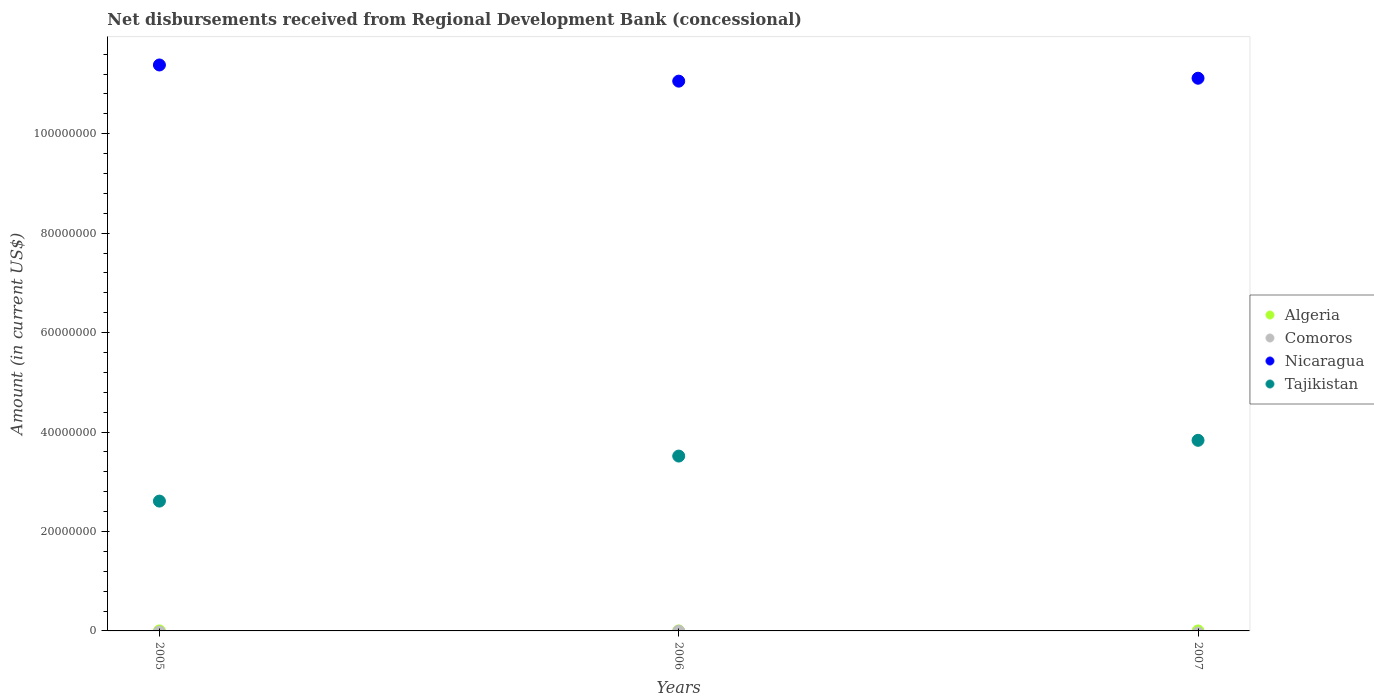How many different coloured dotlines are there?
Provide a short and direct response. 2. What is the amount of disbursements received from Regional Development Bank in Algeria in 2005?
Offer a very short reply. 0. Across all years, what is the maximum amount of disbursements received from Regional Development Bank in Nicaragua?
Your answer should be compact. 1.14e+08. Across all years, what is the minimum amount of disbursements received from Regional Development Bank in Tajikistan?
Provide a succinct answer. 2.61e+07. In which year was the amount of disbursements received from Regional Development Bank in Tajikistan maximum?
Provide a short and direct response. 2007. What is the difference between the amount of disbursements received from Regional Development Bank in Nicaragua in 2005 and that in 2007?
Give a very brief answer. 2.66e+06. What is the difference between the amount of disbursements received from Regional Development Bank in Tajikistan in 2006 and the amount of disbursements received from Regional Development Bank in Comoros in 2005?
Ensure brevity in your answer.  3.52e+07. What is the average amount of disbursements received from Regional Development Bank in Tajikistan per year?
Your answer should be compact. 3.32e+07. In the year 2006, what is the difference between the amount of disbursements received from Regional Development Bank in Tajikistan and amount of disbursements received from Regional Development Bank in Nicaragua?
Provide a succinct answer. -7.54e+07. In how many years, is the amount of disbursements received from Regional Development Bank in Nicaragua greater than 72000000 US$?
Your response must be concise. 3. What is the ratio of the amount of disbursements received from Regional Development Bank in Tajikistan in 2005 to that in 2007?
Keep it short and to the point. 0.68. Is the amount of disbursements received from Regional Development Bank in Nicaragua in 2006 less than that in 2007?
Offer a terse response. Yes. Is the difference between the amount of disbursements received from Regional Development Bank in Tajikistan in 2005 and 2006 greater than the difference between the amount of disbursements received from Regional Development Bank in Nicaragua in 2005 and 2006?
Provide a short and direct response. No. What is the difference between the highest and the second highest amount of disbursements received from Regional Development Bank in Tajikistan?
Keep it short and to the point. 3.17e+06. What is the difference between the highest and the lowest amount of disbursements received from Regional Development Bank in Nicaragua?
Your answer should be very brief. 3.25e+06. In how many years, is the amount of disbursements received from Regional Development Bank in Comoros greater than the average amount of disbursements received from Regional Development Bank in Comoros taken over all years?
Keep it short and to the point. 0. Is the amount of disbursements received from Regional Development Bank in Comoros strictly less than the amount of disbursements received from Regional Development Bank in Tajikistan over the years?
Offer a terse response. Yes. Are the values on the major ticks of Y-axis written in scientific E-notation?
Your answer should be compact. No. Does the graph contain any zero values?
Your answer should be compact. Yes. Does the graph contain grids?
Your response must be concise. No. Where does the legend appear in the graph?
Your answer should be compact. Center right. What is the title of the graph?
Provide a short and direct response. Net disbursements received from Regional Development Bank (concessional). Does "Spain" appear as one of the legend labels in the graph?
Make the answer very short. No. What is the Amount (in current US$) in Nicaragua in 2005?
Offer a very short reply. 1.14e+08. What is the Amount (in current US$) of Tajikistan in 2005?
Offer a terse response. 2.61e+07. What is the Amount (in current US$) in Nicaragua in 2006?
Your answer should be compact. 1.11e+08. What is the Amount (in current US$) in Tajikistan in 2006?
Your answer should be compact. 3.52e+07. What is the Amount (in current US$) in Nicaragua in 2007?
Provide a succinct answer. 1.11e+08. What is the Amount (in current US$) in Tajikistan in 2007?
Ensure brevity in your answer.  3.83e+07. Across all years, what is the maximum Amount (in current US$) of Nicaragua?
Your answer should be compact. 1.14e+08. Across all years, what is the maximum Amount (in current US$) of Tajikistan?
Keep it short and to the point. 3.83e+07. Across all years, what is the minimum Amount (in current US$) in Nicaragua?
Make the answer very short. 1.11e+08. Across all years, what is the minimum Amount (in current US$) of Tajikistan?
Ensure brevity in your answer.  2.61e+07. What is the total Amount (in current US$) of Algeria in the graph?
Provide a short and direct response. 0. What is the total Amount (in current US$) of Comoros in the graph?
Provide a short and direct response. 0. What is the total Amount (in current US$) of Nicaragua in the graph?
Your answer should be compact. 3.36e+08. What is the total Amount (in current US$) of Tajikistan in the graph?
Your response must be concise. 9.96e+07. What is the difference between the Amount (in current US$) of Nicaragua in 2005 and that in 2006?
Ensure brevity in your answer.  3.25e+06. What is the difference between the Amount (in current US$) of Tajikistan in 2005 and that in 2006?
Your response must be concise. -9.06e+06. What is the difference between the Amount (in current US$) in Nicaragua in 2005 and that in 2007?
Provide a succinct answer. 2.66e+06. What is the difference between the Amount (in current US$) of Tajikistan in 2005 and that in 2007?
Provide a succinct answer. -1.22e+07. What is the difference between the Amount (in current US$) in Nicaragua in 2006 and that in 2007?
Offer a terse response. -5.87e+05. What is the difference between the Amount (in current US$) of Tajikistan in 2006 and that in 2007?
Offer a terse response. -3.17e+06. What is the difference between the Amount (in current US$) in Nicaragua in 2005 and the Amount (in current US$) in Tajikistan in 2006?
Keep it short and to the point. 7.87e+07. What is the difference between the Amount (in current US$) in Nicaragua in 2005 and the Amount (in current US$) in Tajikistan in 2007?
Provide a succinct answer. 7.55e+07. What is the difference between the Amount (in current US$) of Nicaragua in 2006 and the Amount (in current US$) of Tajikistan in 2007?
Give a very brief answer. 7.22e+07. What is the average Amount (in current US$) in Algeria per year?
Ensure brevity in your answer.  0. What is the average Amount (in current US$) in Comoros per year?
Offer a terse response. 0. What is the average Amount (in current US$) of Nicaragua per year?
Keep it short and to the point. 1.12e+08. What is the average Amount (in current US$) of Tajikistan per year?
Your answer should be very brief. 3.32e+07. In the year 2005, what is the difference between the Amount (in current US$) of Nicaragua and Amount (in current US$) of Tajikistan?
Your response must be concise. 8.77e+07. In the year 2006, what is the difference between the Amount (in current US$) of Nicaragua and Amount (in current US$) of Tajikistan?
Your response must be concise. 7.54e+07. In the year 2007, what is the difference between the Amount (in current US$) in Nicaragua and Amount (in current US$) in Tajikistan?
Offer a very short reply. 7.28e+07. What is the ratio of the Amount (in current US$) of Nicaragua in 2005 to that in 2006?
Keep it short and to the point. 1.03. What is the ratio of the Amount (in current US$) of Tajikistan in 2005 to that in 2006?
Offer a terse response. 0.74. What is the ratio of the Amount (in current US$) of Nicaragua in 2005 to that in 2007?
Offer a terse response. 1.02. What is the ratio of the Amount (in current US$) of Tajikistan in 2005 to that in 2007?
Give a very brief answer. 0.68. What is the ratio of the Amount (in current US$) in Tajikistan in 2006 to that in 2007?
Ensure brevity in your answer.  0.92. What is the difference between the highest and the second highest Amount (in current US$) of Nicaragua?
Ensure brevity in your answer.  2.66e+06. What is the difference between the highest and the second highest Amount (in current US$) of Tajikistan?
Offer a very short reply. 3.17e+06. What is the difference between the highest and the lowest Amount (in current US$) of Nicaragua?
Give a very brief answer. 3.25e+06. What is the difference between the highest and the lowest Amount (in current US$) in Tajikistan?
Offer a terse response. 1.22e+07. 